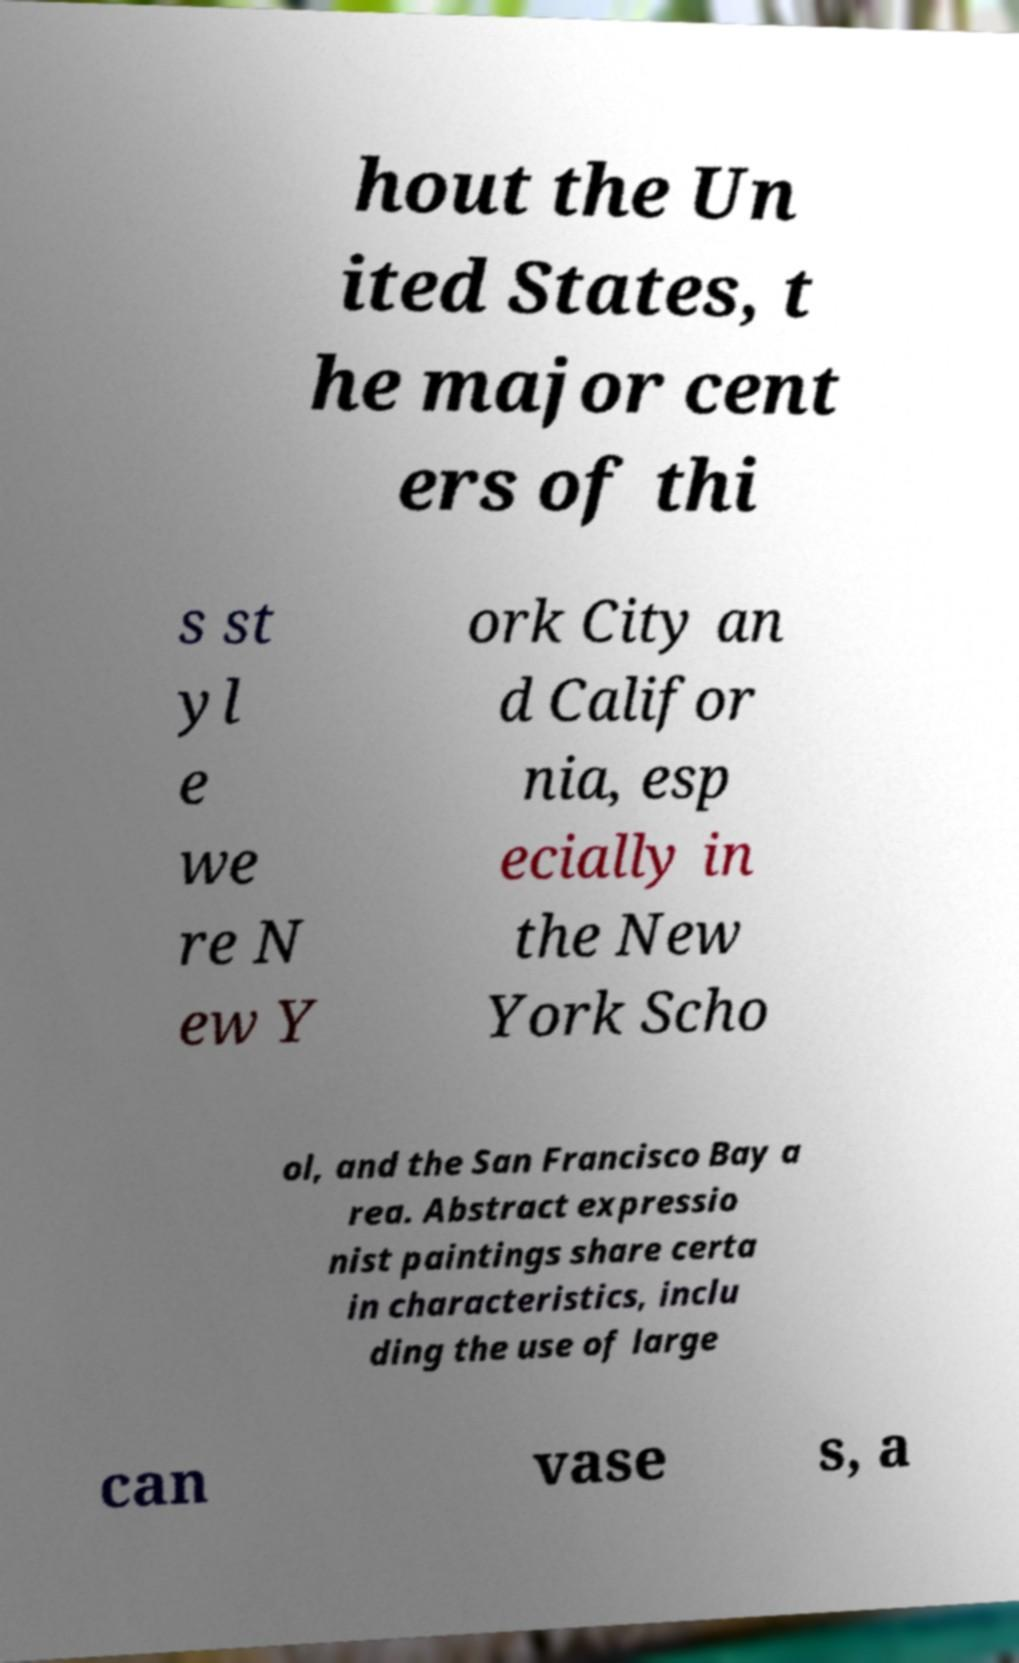What messages or text are displayed in this image? I need them in a readable, typed format. hout the Un ited States, t he major cent ers of thi s st yl e we re N ew Y ork City an d Califor nia, esp ecially in the New York Scho ol, and the San Francisco Bay a rea. Abstract expressio nist paintings share certa in characteristics, inclu ding the use of large can vase s, a 